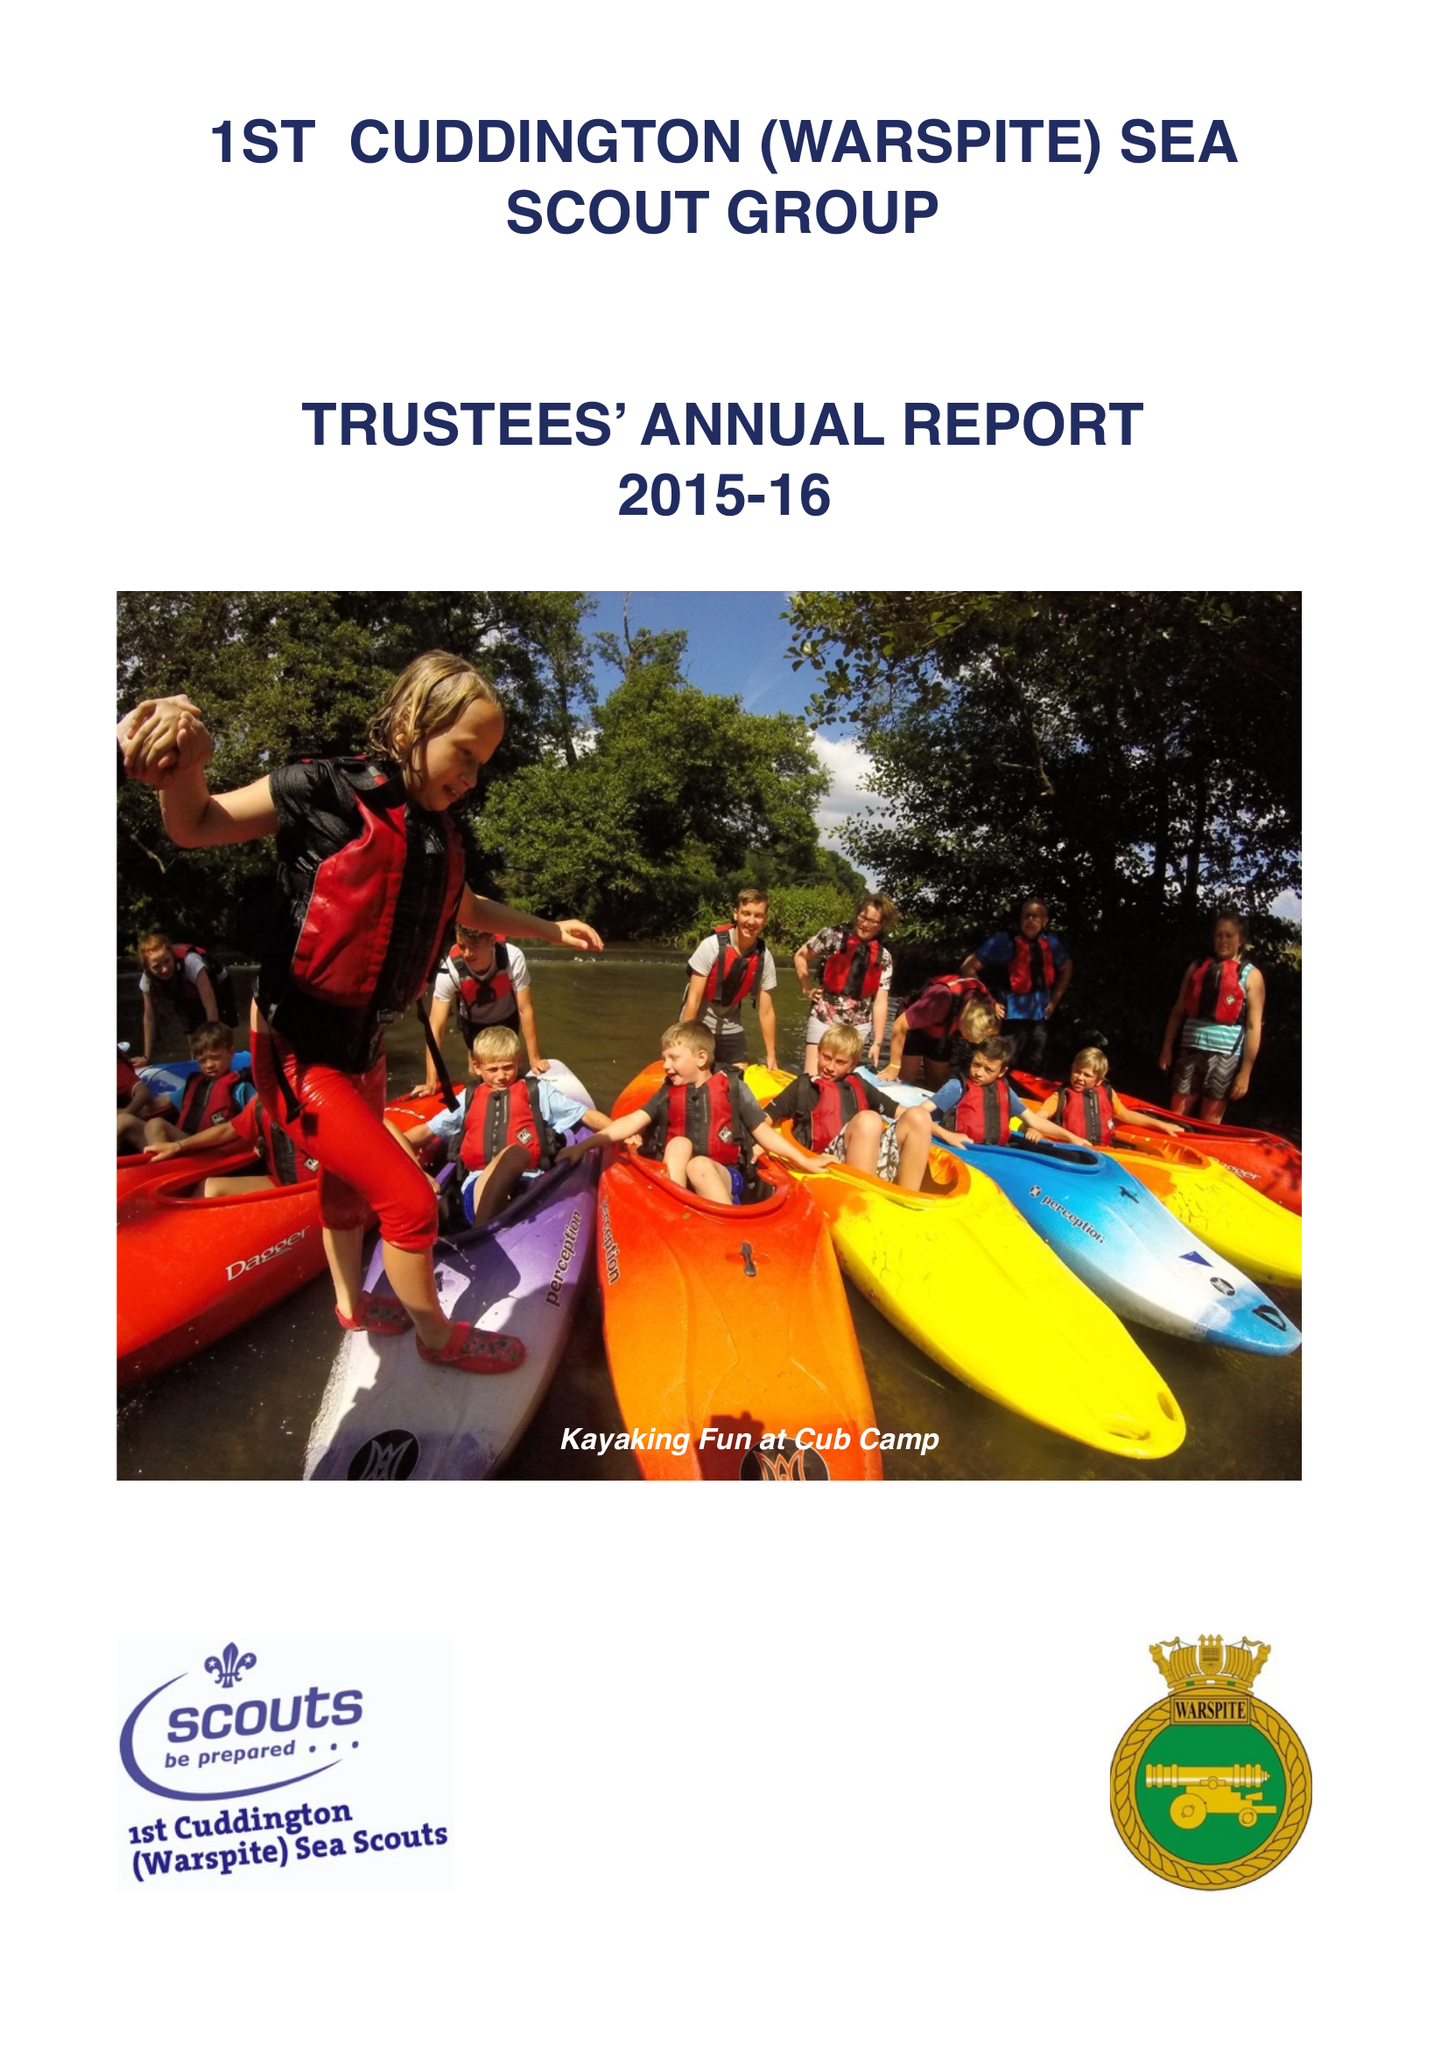What is the value for the address__postcode?
Answer the question using a single word or phrase. KT17 2PJ 